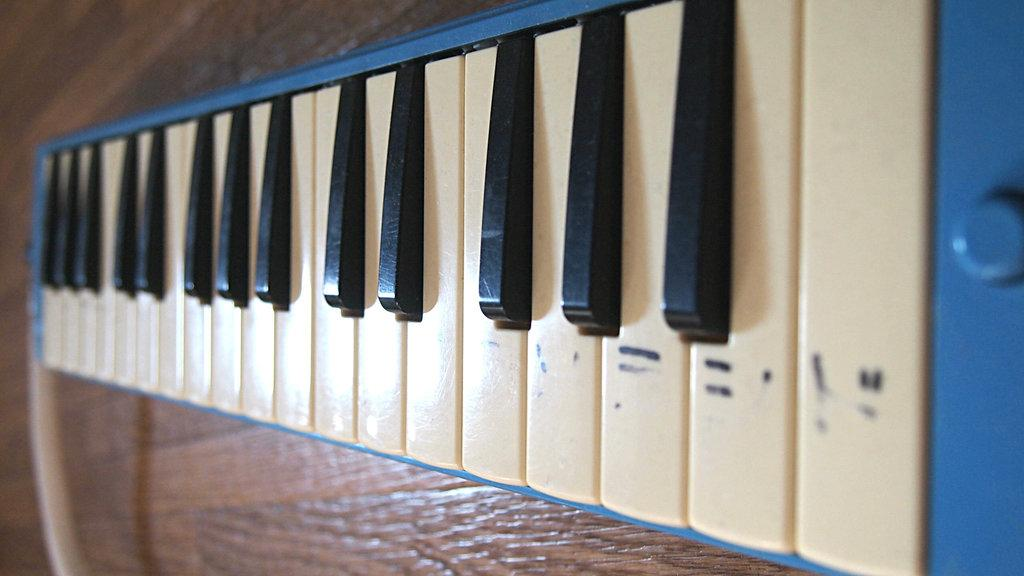What is the main object in the image? There is a piano in the image. What is the color of the buttons on the piano? The piano has white color buttons. How does the piano contribute to pollution in the image? The piano does not contribute to pollution in the image; it is an inanimate object. Is there a maid present in the image? There is no mention of a maid in the provided facts, so it cannot be determined from the image. 